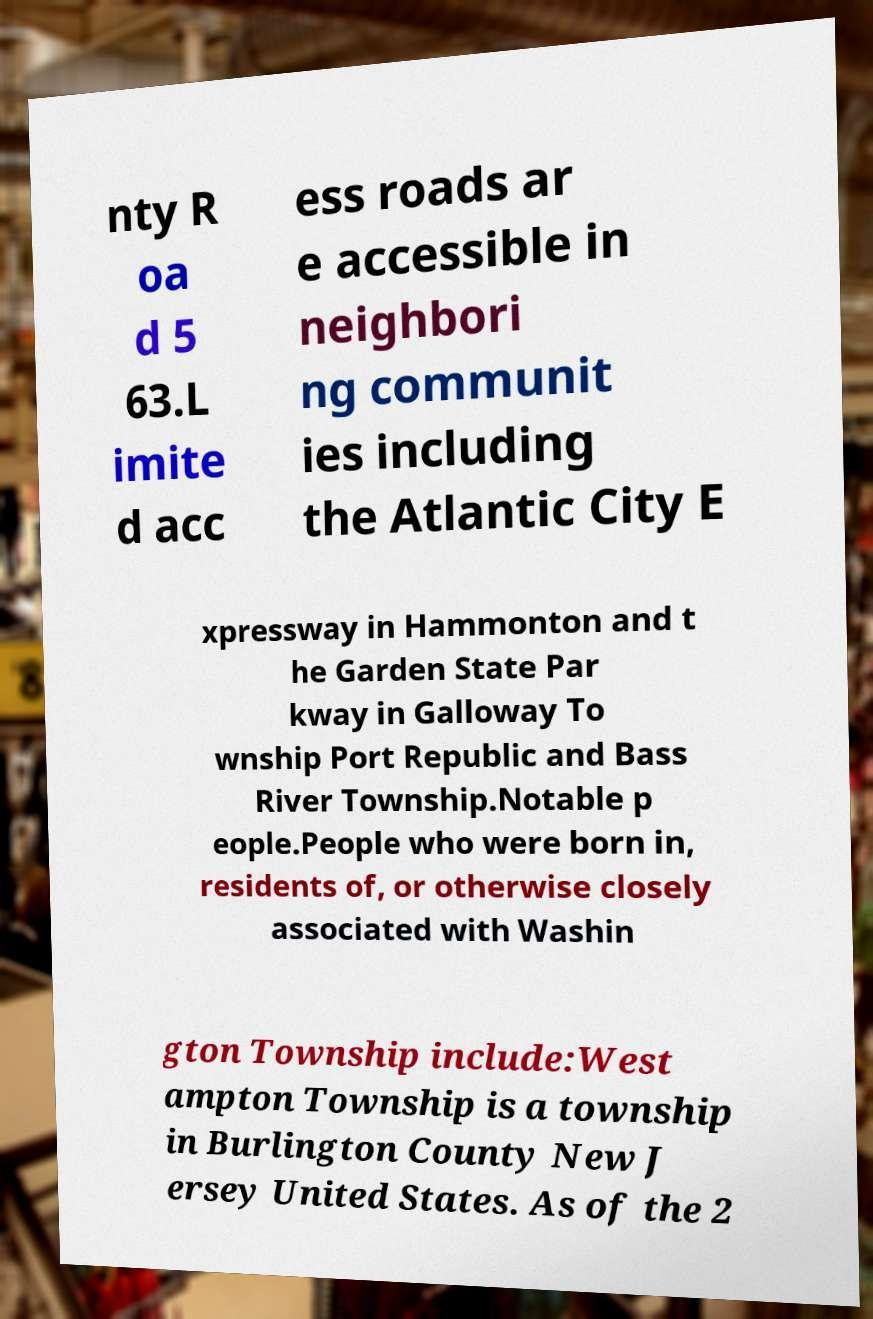For documentation purposes, I need the text within this image transcribed. Could you provide that? nty R oa d 5 63.L imite d acc ess roads ar e accessible in neighbori ng communit ies including the Atlantic City E xpressway in Hammonton and t he Garden State Par kway in Galloway To wnship Port Republic and Bass River Township.Notable p eople.People who were born in, residents of, or otherwise closely associated with Washin gton Township include:West ampton Township is a township in Burlington County New J ersey United States. As of the 2 